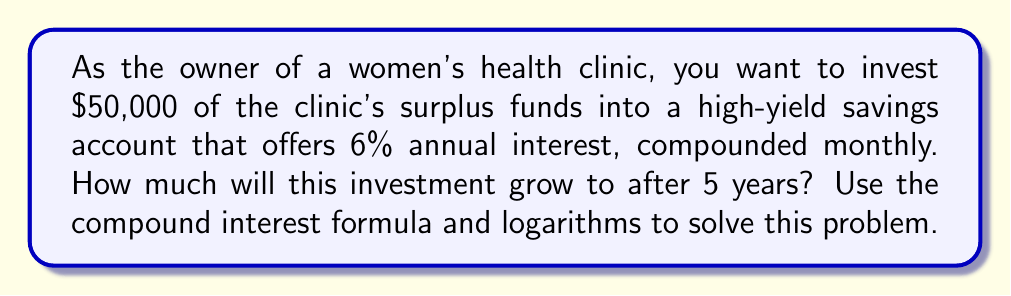What is the answer to this math problem? To solve this problem, we'll use the compound interest formula and logarithms. Let's break it down step-by-step:

1) The compound interest formula is:
   $A = P(1 + \frac{r}{n})^{nt}$

   Where:
   $A$ = final amount
   $P$ = principal (initial investment)
   $r$ = annual interest rate (as a decimal)
   $n$ = number of times interest is compounded per year
   $t$ = number of years

2) Given information:
   $P = 50,000$
   $r = 0.06$ (6% expressed as a decimal)
   $n = 12$ (compounded monthly)
   $t = 5$ years

3) Let's substitute these values into the formula:
   $A = 50,000(1 + \frac{0.06}{12})^{12 \cdot 5}$

4) Simplify inside the parentheses:
   $A = 50,000(1 + 0.005)^{60}$

5) To solve this, we can use logarithms. Let's apply log to both sides:
   $\log A = \log(50,000(1.005)^{60})$

6) Using the logarithm property $\log(xy) = \log x + \log y$:
   $\log A = \log 50,000 + 60 \log 1.005$

7) Now we can calculate:
   $\log A = 4.69897 + 60 \cdot 0.00217 = 4.82917$

8) To get A, we apply the antilog (10^x):
   $A = 10^{4.82917} = 67,439.53$

Therefore, after 5 years, the investment will grow to $67,439.53.
Answer: $67,439.53 